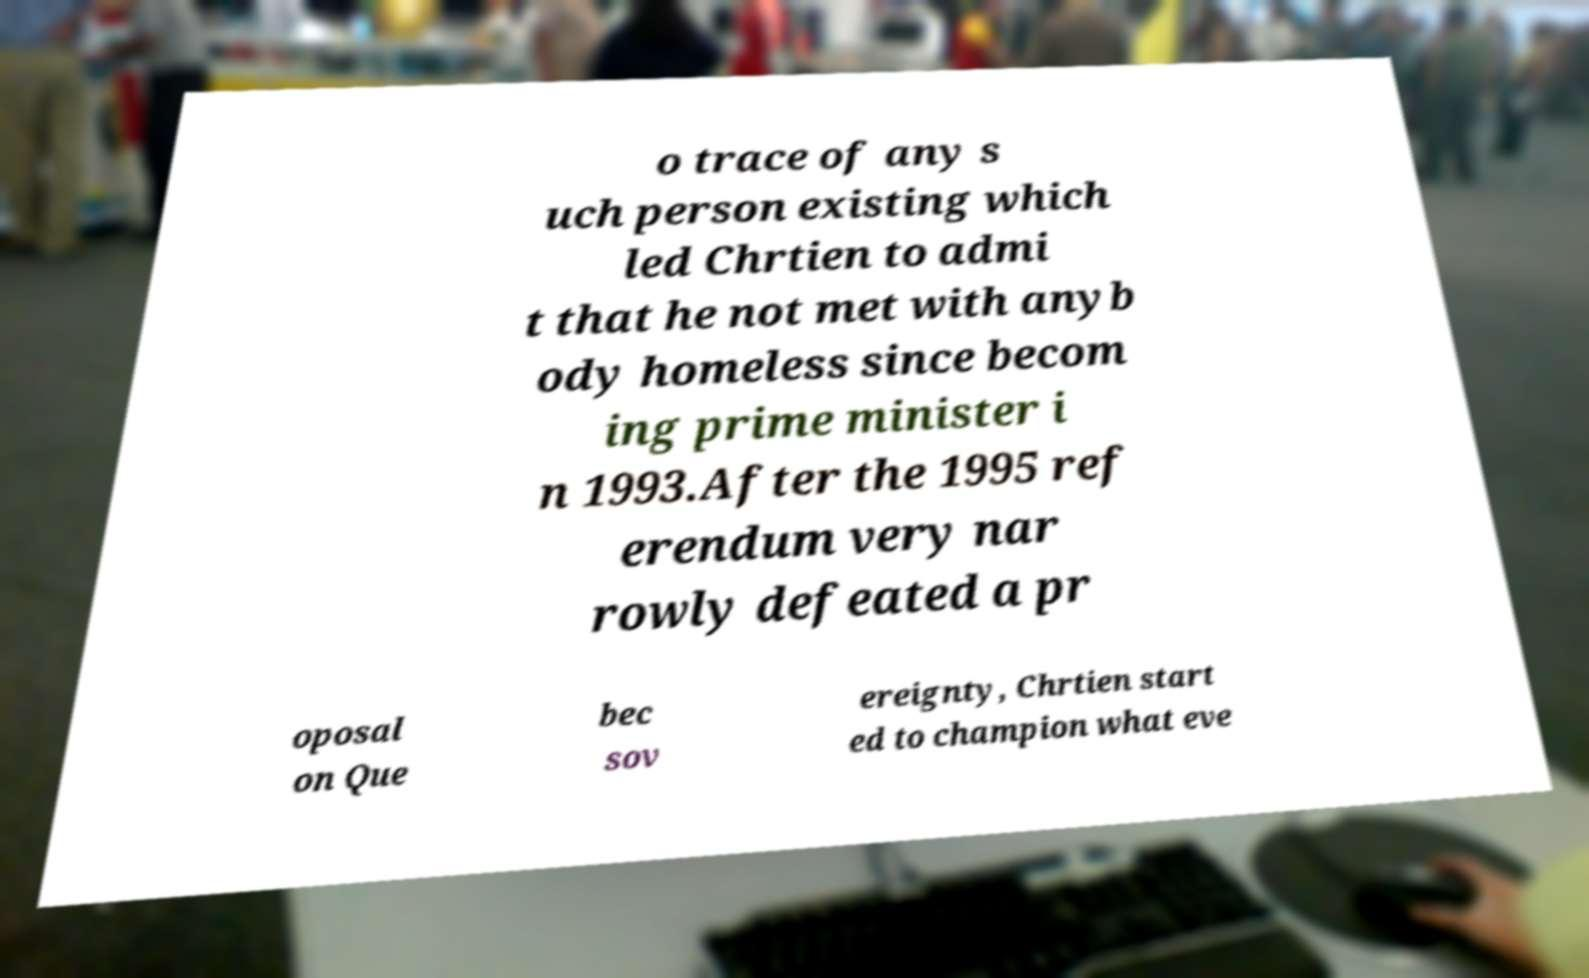Could you assist in decoding the text presented in this image and type it out clearly? o trace of any s uch person existing which led Chrtien to admi t that he not met with anyb ody homeless since becom ing prime minister i n 1993.After the 1995 ref erendum very nar rowly defeated a pr oposal on Que bec sov ereignty, Chrtien start ed to champion what eve 